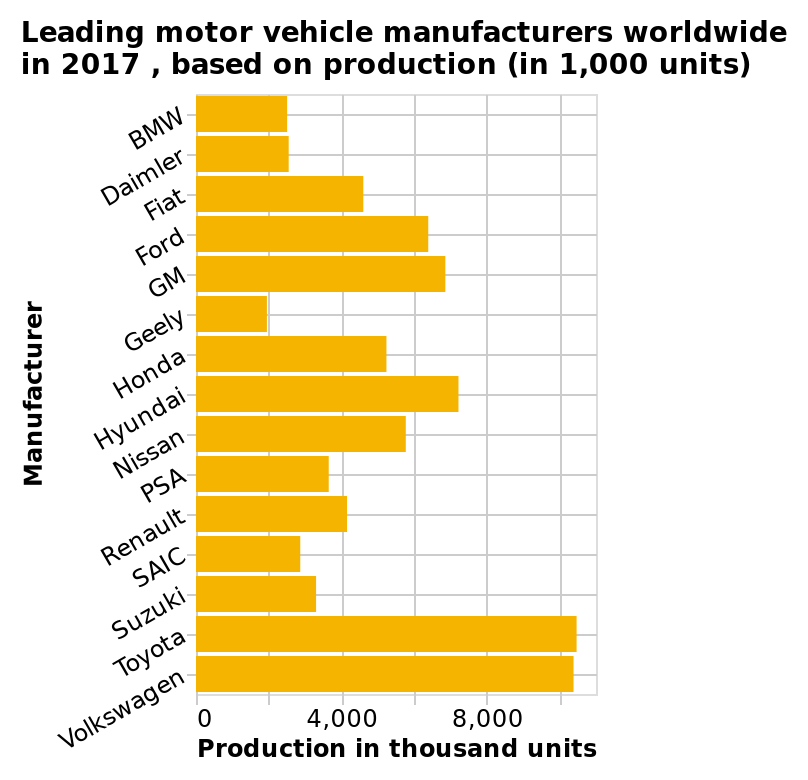<image>
please enumerates aspects of the construction of the chart Leading motor vehicle manufacturers worldwide in 2017 , based on production (in 1,000 units) is a bar chart. Along the x-axis, Production in thousand units is measured using a linear scale from 0 to 10,000. Manufacturer is plotted using a categorical scale starting at BMW and ending at Volkswagen on the y-axis. Which manufacturer is plotted last on the y-axis? Volkswagen is plotted last on the y-axis. What is the range of the x-axis on the bar chart?  The x-axis ranges from 0 to 10,000 units. Which manufacturer is plotted first on the y-axis? BMW is plotted first on the y-axis. How many units of cars does Geely produce?  Geely produces around 2000 units of cars. 